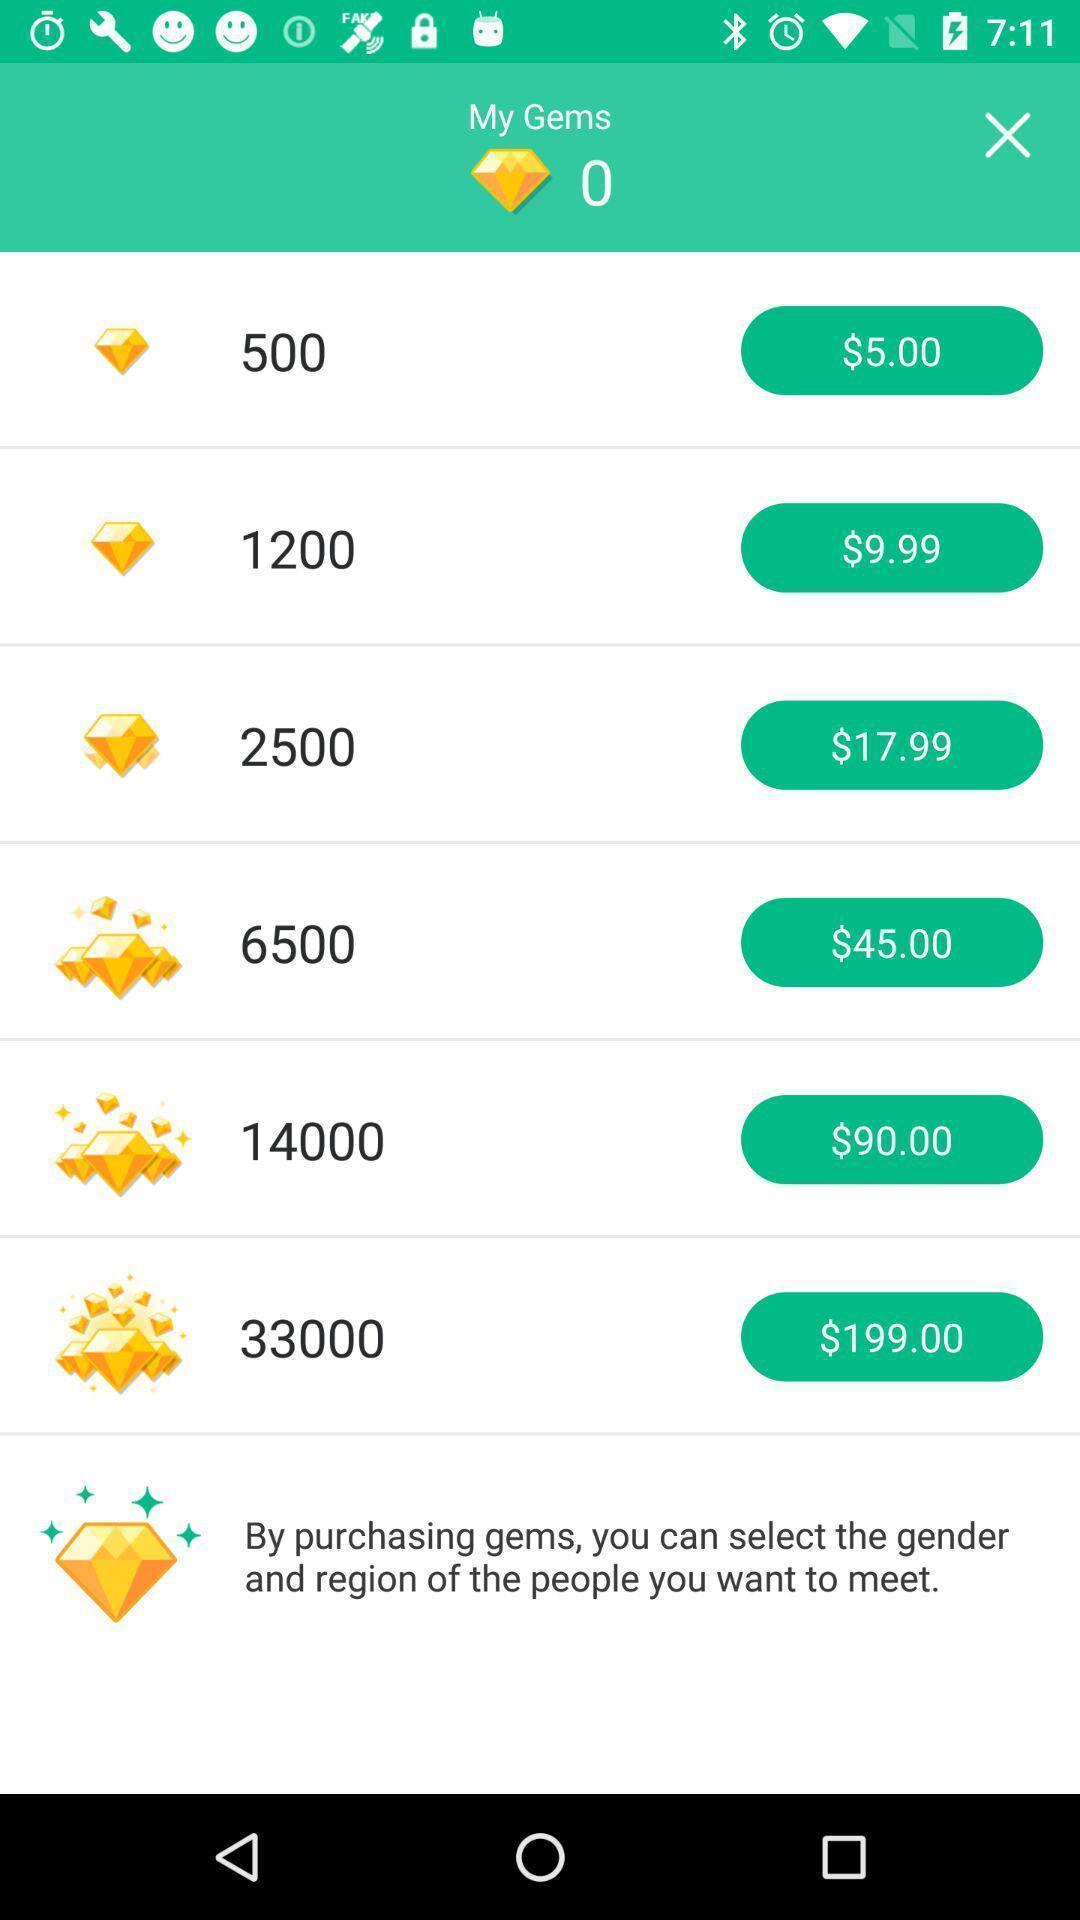What details can you identify in this image? Screen displaying the page of a social app. 